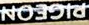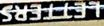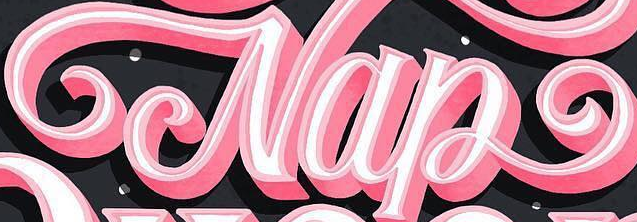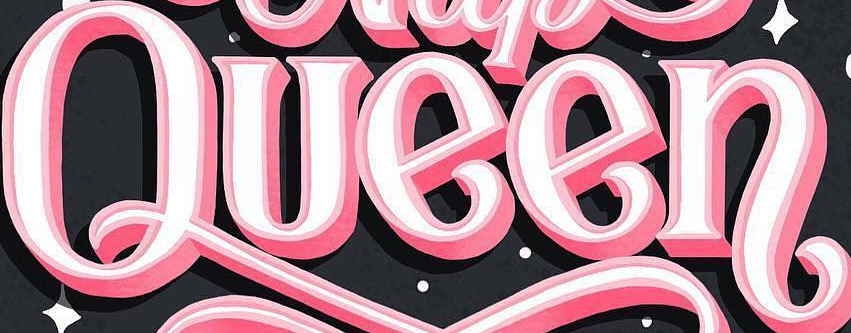Read the text content from these images in order, separated by a semicolon. PIGEON; LETTERS; Nap; Queen 